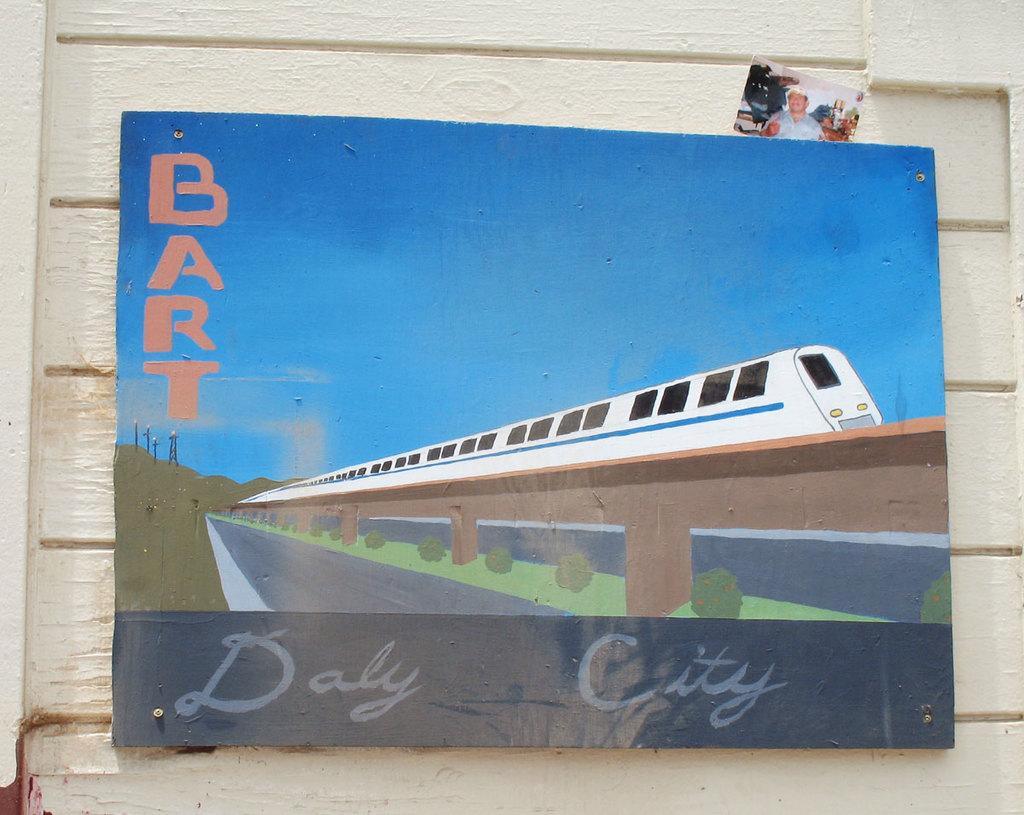Could you give a brief overview of what you see in this image? This is a board, which is fixed to the wall. I can see the picture of a train, bushes, hill and letters on the board. This looks like a photo. 